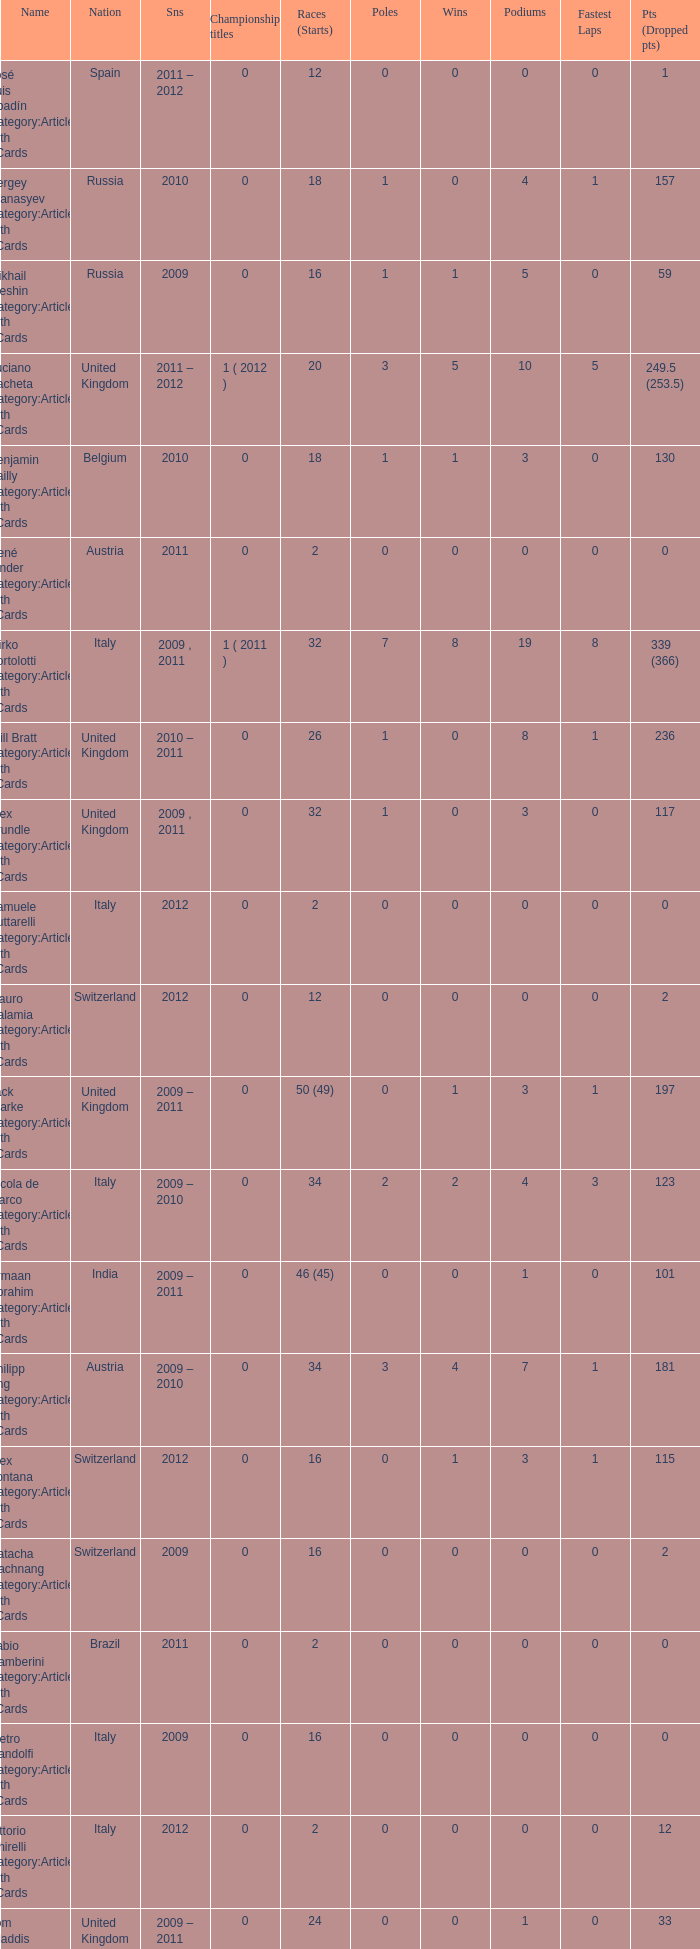What was the least amount of wins? 0.0. 